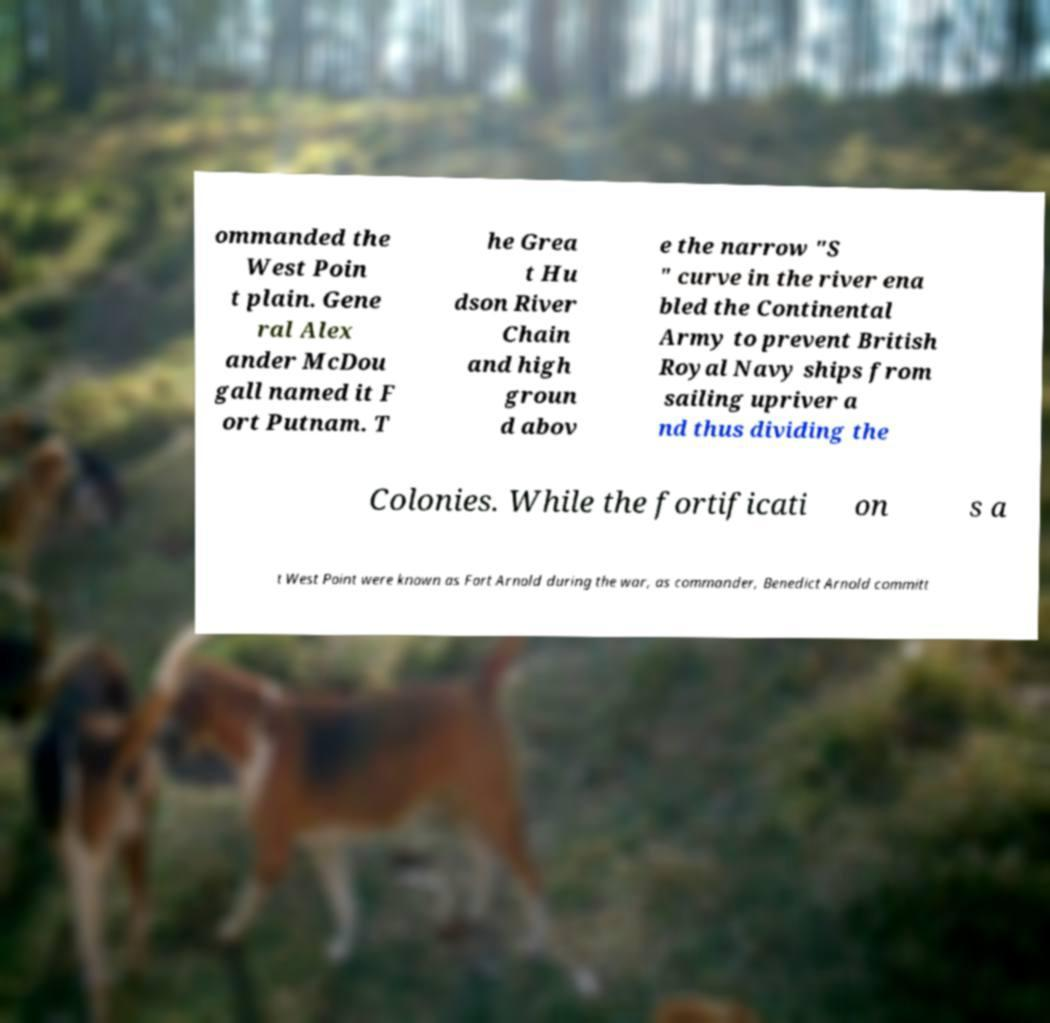Please identify and transcribe the text found in this image. ommanded the West Poin t plain. Gene ral Alex ander McDou gall named it F ort Putnam. T he Grea t Hu dson River Chain and high groun d abov e the narrow "S " curve in the river ena bled the Continental Army to prevent British Royal Navy ships from sailing upriver a nd thus dividing the Colonies. While the fortificati on s a t West Point were known as Fort Arnold during the war, as commander, Benedict Arnold committ 